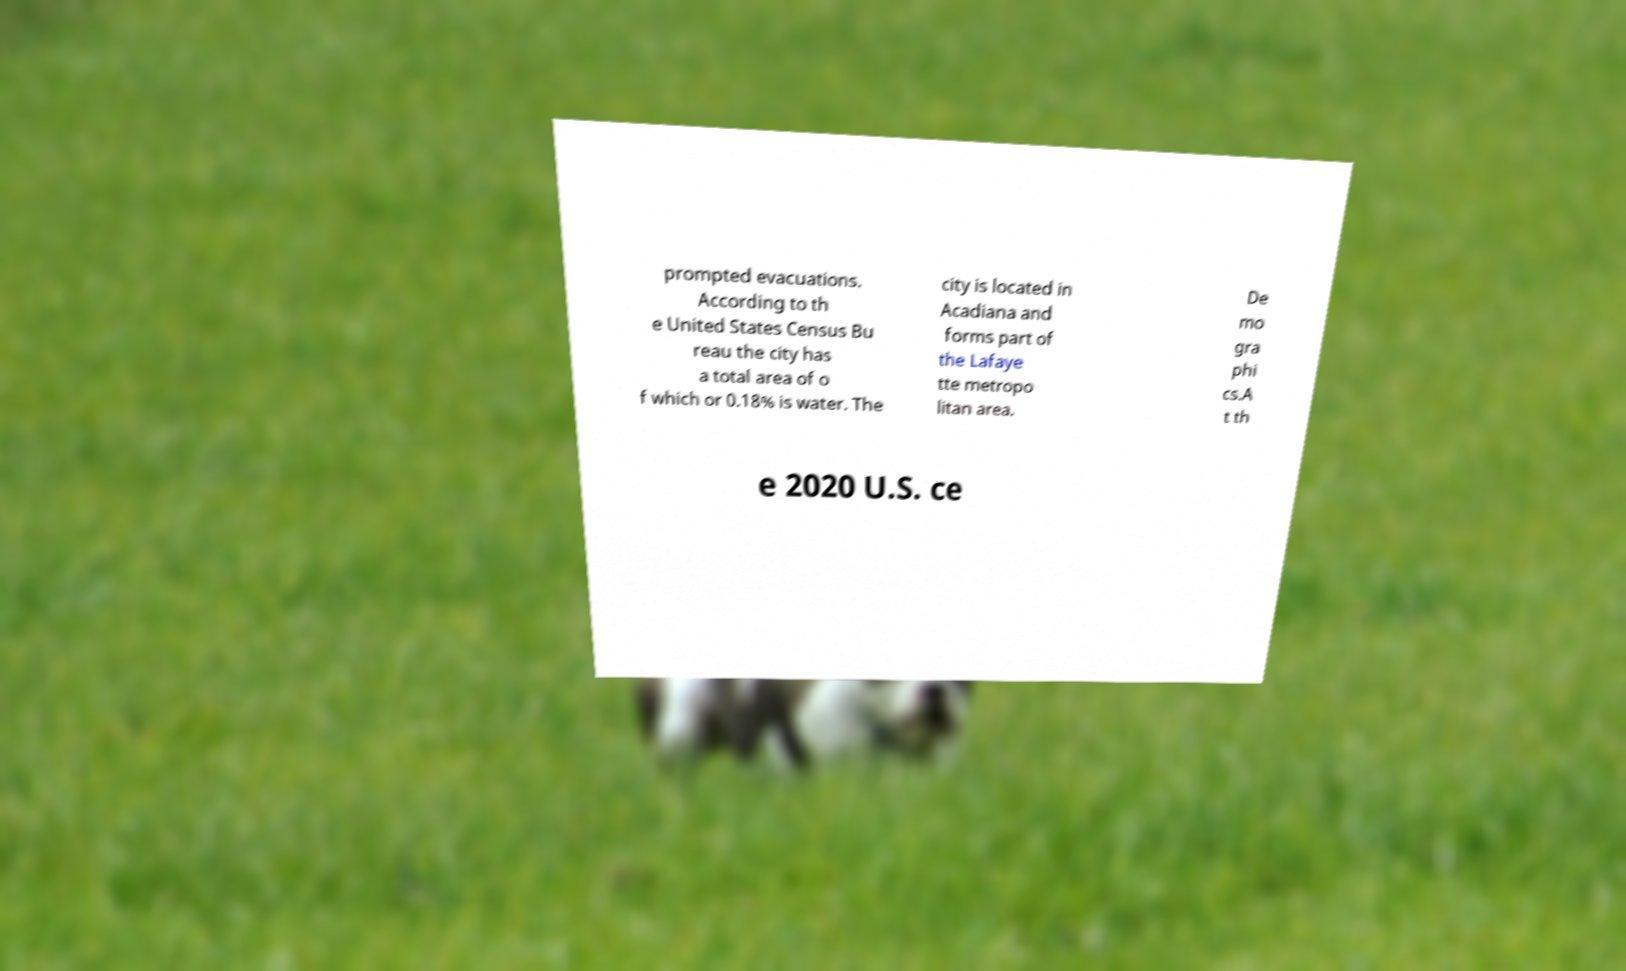Could you extract and type out the text from this image? prompted evacuations. According to th e United States Census Bu reau the city has a total area of o f which or 0.18% is water. The city is located in Acadiana and forms part of the Lafaye tte metropo litan area. De mo gra phi cs.A t th e 2020 U.S. ce 